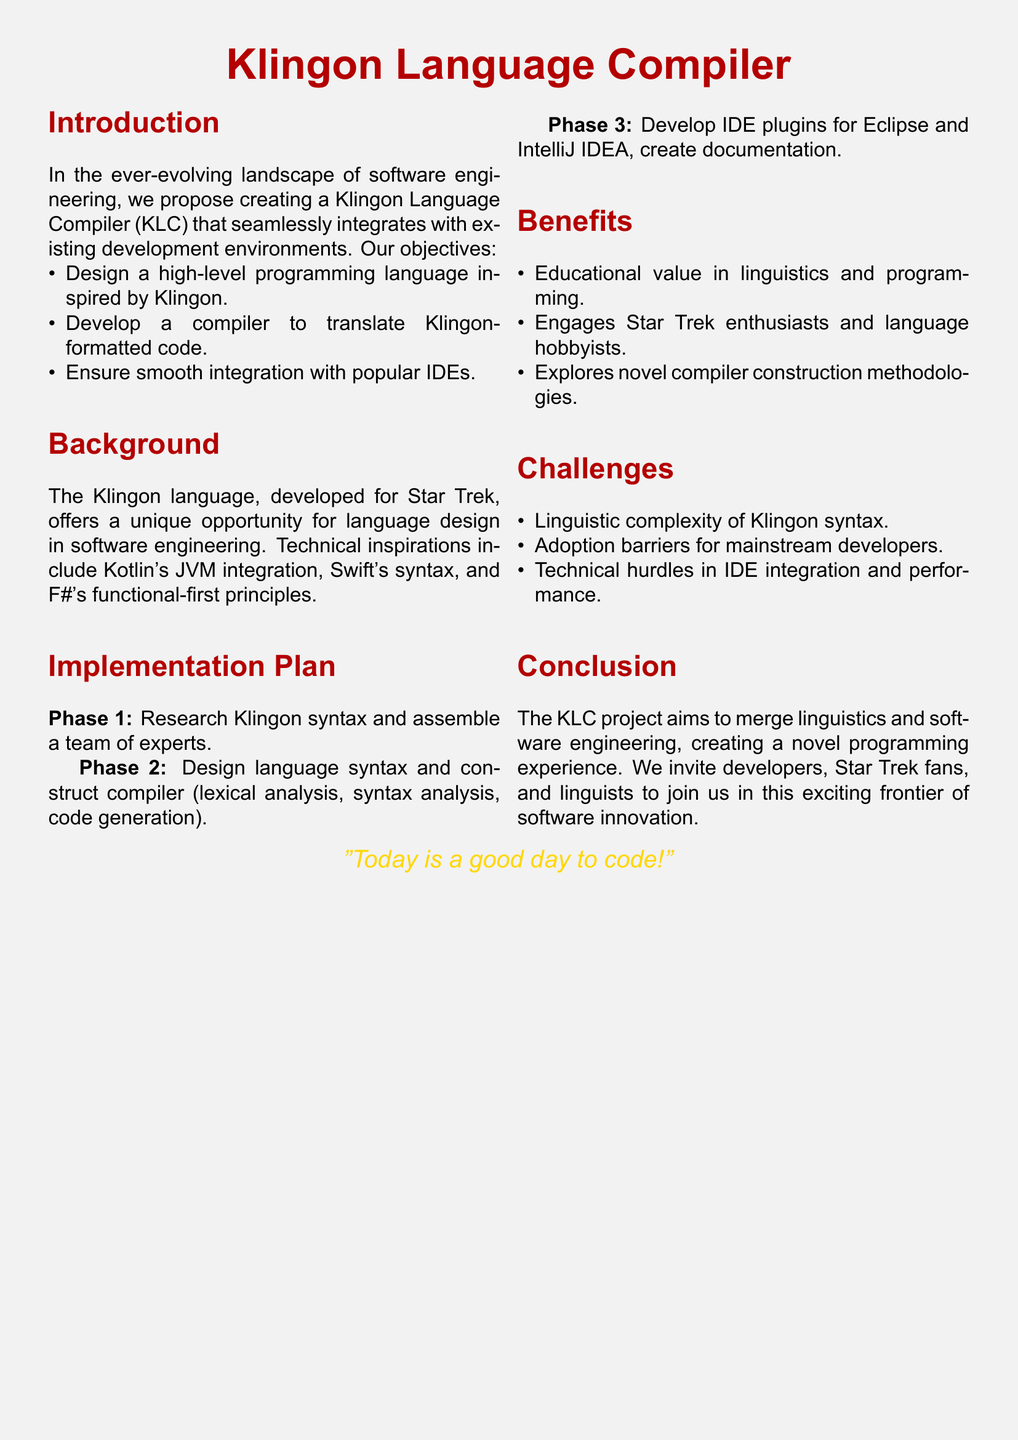What is the name of the project? The project aims to create a compiler for a language inspired by Klingon, titled "Klingon Language Compiler".
Answer: Klingon Language Compiler What is the primary goal of the Klingon Language Compiler? The main objective is to design a high-level programming language inspired by Klingon.
Answer: Designing a high-level programming language What is the first phase of the implementation plan? The first phase involves researching Klingon syntax and assembling a team.
Answer: Research Klingon syntax Which two IDEs are mentioned for plugin development? The proposal lists Eclipse and IntelliJ IDEA as the IDEs for integration.
Answer: Eclipse and IntelliJ IDEA What color is used for the project title in the document? The title is displayed in a specific color defined as "klingonred".
Answer: klingonred What challenge involves mainstream developers? One of the challenges identified is the adoption barriers for mainstream developers.
Answer: Adoption barriers How many phases are in the implementation plan? The document outlines three distinct phases in the plan.
Answer: Three What is the educational value mentioned in the benefits section? The proposal states there is educational value in linguistics and programming.
Answer: Linguistics and programming What quote is included at the end of the document? The document features a quote that emphasizes the positive attitude towards coding.
Answer: "Today is a good day to code!" 